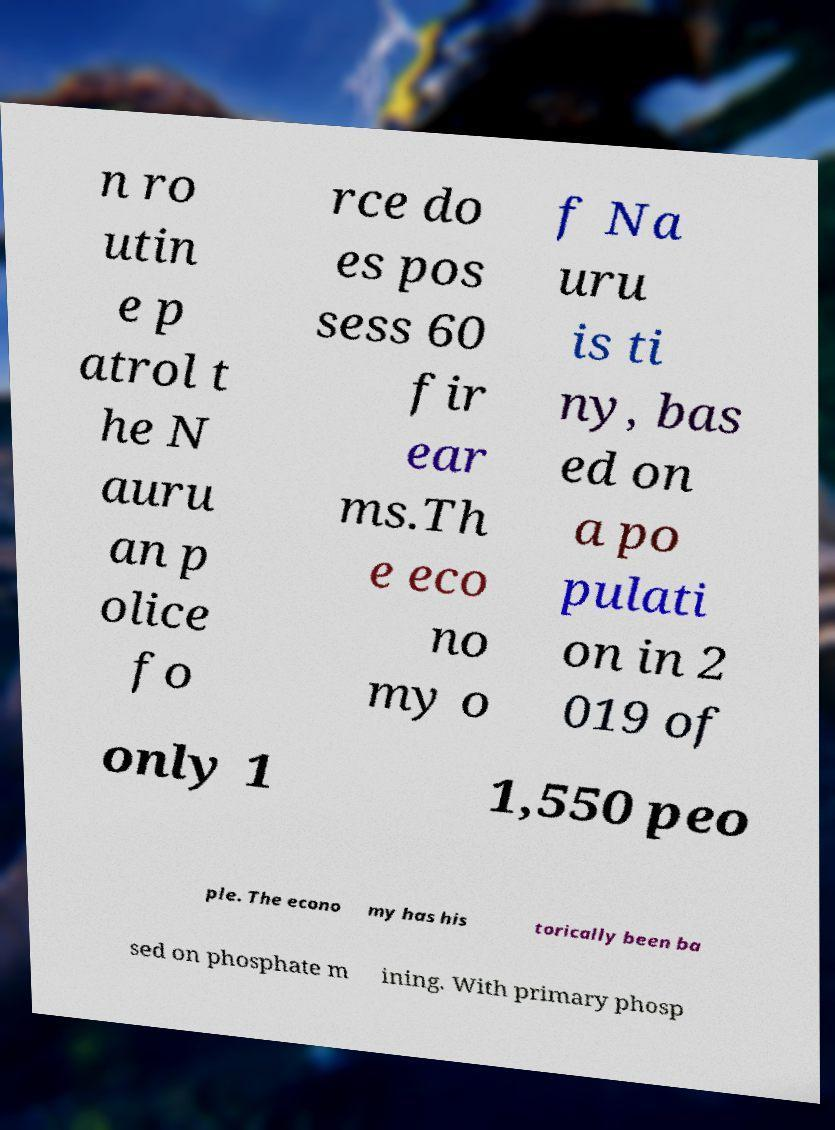There's text embedded in this image that I need extracted. Can you transcribe it verbatim? n ro utin e p atrol t he N auru an p olice fo rce do es pos sess 60 fir ear ms.Th e eco no my o f Na uru is ti ny, bas ed on a po pulati on in 2 019 of only 1 1,550 peo ple. The econo my has his torically been ba sed on phosphate m ining. With primary phosp 